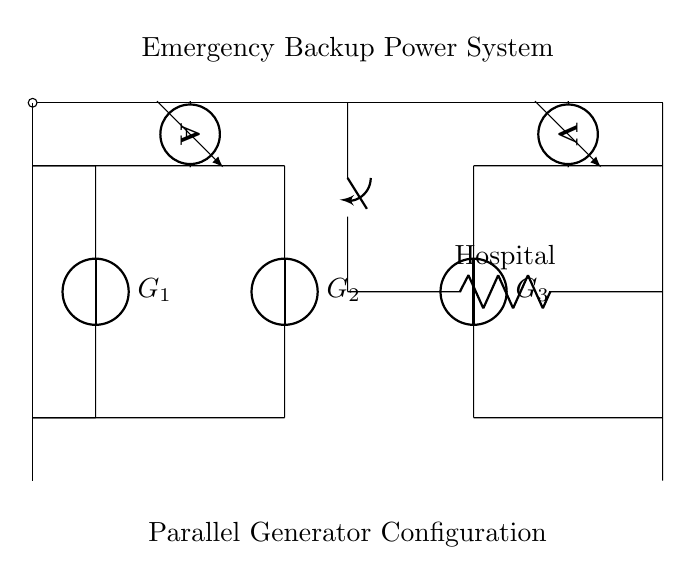What components are present in this circuit? The circuit includes three generators (G1, G2, G3), a load labeled as Hospital, a switch, an ammeter, and a voltmeter. Each component is marked clearly in the diagram.
Answer: Three generators, load, switch, ammeter, voltmeter What type of circuit configuration is used here? The configuration illustrated is a parallel circuit, as multiple generators are connected to the same load, allowing for redundancy and reliability in supplying power.
Answer: Parallel How many generators are connected to the load? There are three generators (G1, G2, G3) connected to the load. Each generator is shown connected in parallel to the load for redundancy.
Answer: Three What is the purpose of the switch in this circuit? The switch allows the operator to control the flow of electricity to the load (hospital), enabling them to turn the generators on or off as needed.
Answer: Control flow What would happen if one generator fails? If one generator fails, the other generators remain operational since they are in parallel, maintaining power supply to the hospital without interruption.
Answer: Power supply maintained What does the ammeter measure in this circuit? The ammeter measures the current flowing from the parallel configuration of generators towards the load, providing information about power distribution.
Answer: Current What information does the voltmeter provide in this circuit? The voltmeter measures the voltage across the load (hospital), indicating the potential difference supplied by the generators to ensure proper operation.
Answer: Voltage 